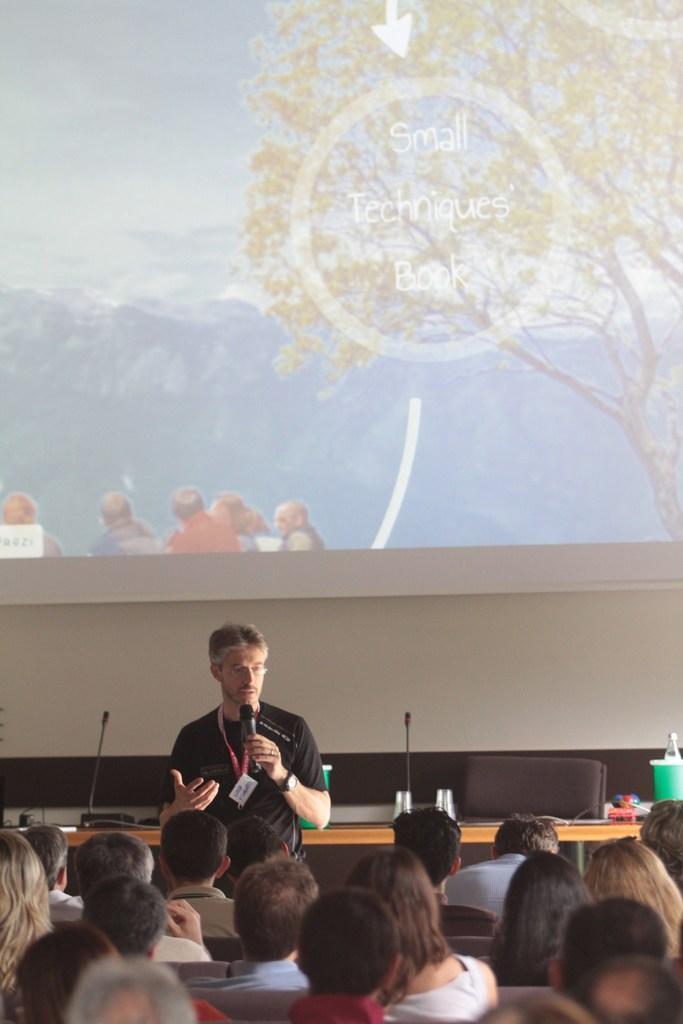In one or two sentences, can you explain what this image depicts? In this image we can see people and there is a man holding a mike with his hand. Here we can see a table, chair, glasses, bottles, mikes, and few objects. In the background we can see wall and a screen. On the screen we can see people, tree, sky, and some information. 